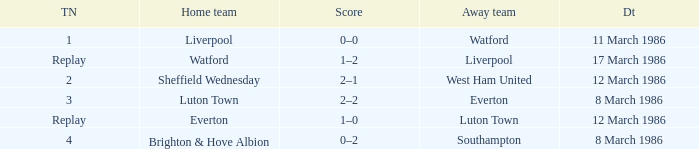What tie happened with Southampton? 4.0. 